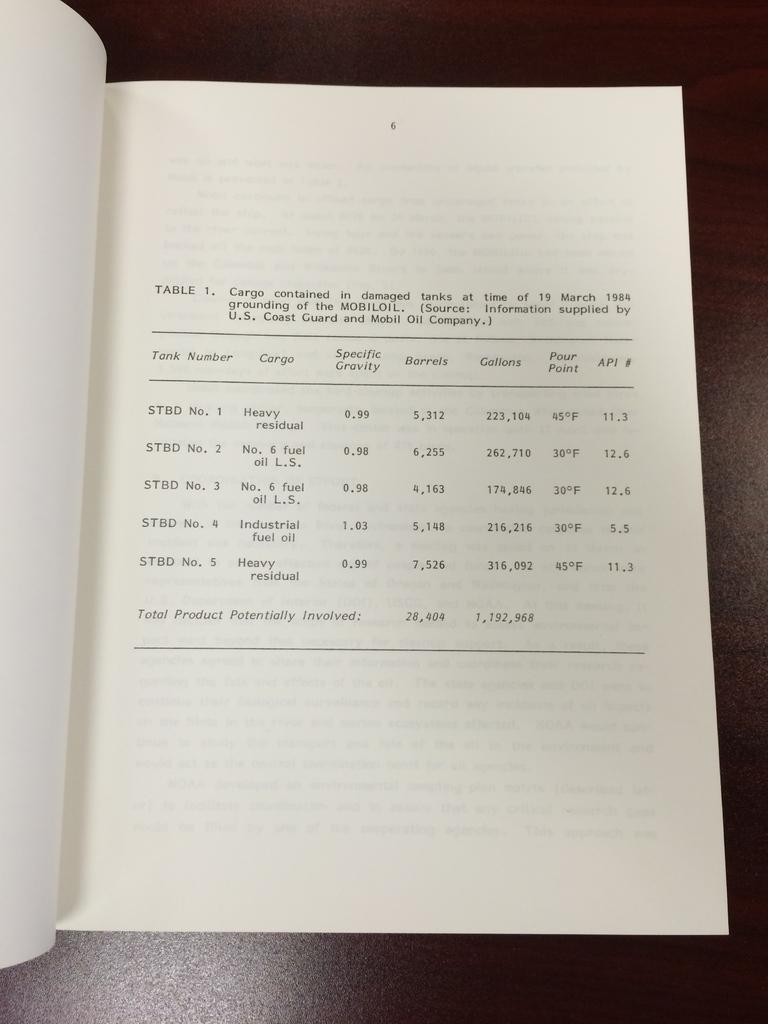<image>
Render a clear and concise summary of the photo. A log book listing the cargo on a ship, such as six barrels of oil. 